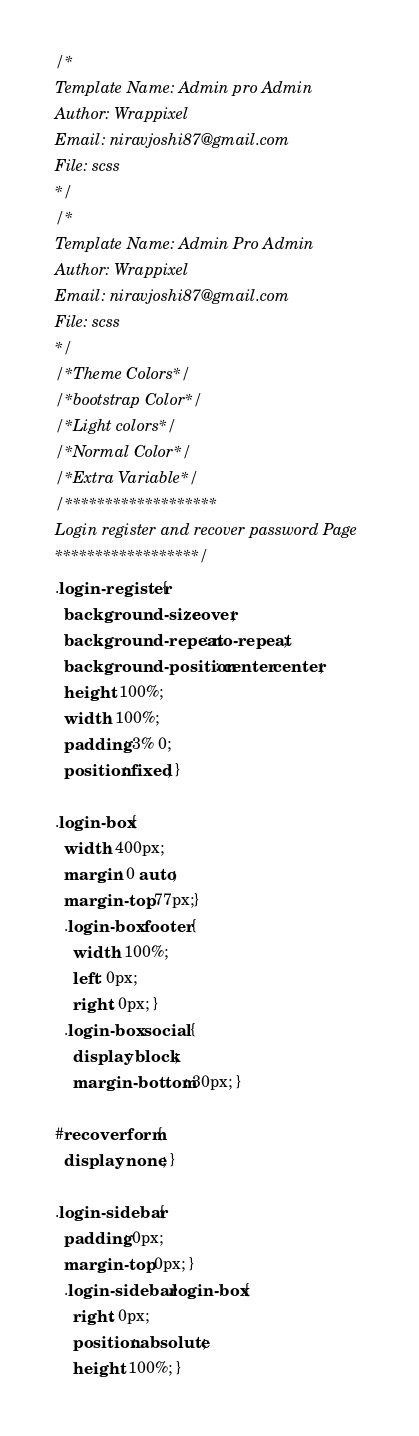<code> <loc_0><loc_0><loc_500><loc_500><_CSS_>/*
Template Name: Admin pro Admin
Author: Wrappixel
Email: niravjoshi87@gmail.com
File: scss
*/
/*
Template Name: Admin Pro Admin
Author: Wrappixel
Email: niravjoshi87@gmail.com
File: scss
*/
/*Theme Colors*/
/*bootstrap Color*/
/*Light colors*/
/*Normal Color*/
/*Extra Variable*/
/*******************
Login register and recover password Page
******************/
.login-register {
  background-size: cover;
  background-repeat: no-repeat;
  background-position: center center;
  height: 100%;
  width: 100%;
  padding: 3% 0;
  position: fixed; }

.login-box {
  width: 400px;
  margin: 0 auto;
  margin-top: 77px;}
  .login-box .footer {
    width: 100%;
    left: 0px;
    right: 0px; }
  .login-box .social {
    display: block;
    margin-bottom: 30px; }

#recoverform {
  display: none; }

.login-sidebar {
  padding: 0px;
  margin-top: 0px; }
  .login-sidebar .login-box {
    right: 0px;
    position: absolute;
    height: 100%; }
</code> 